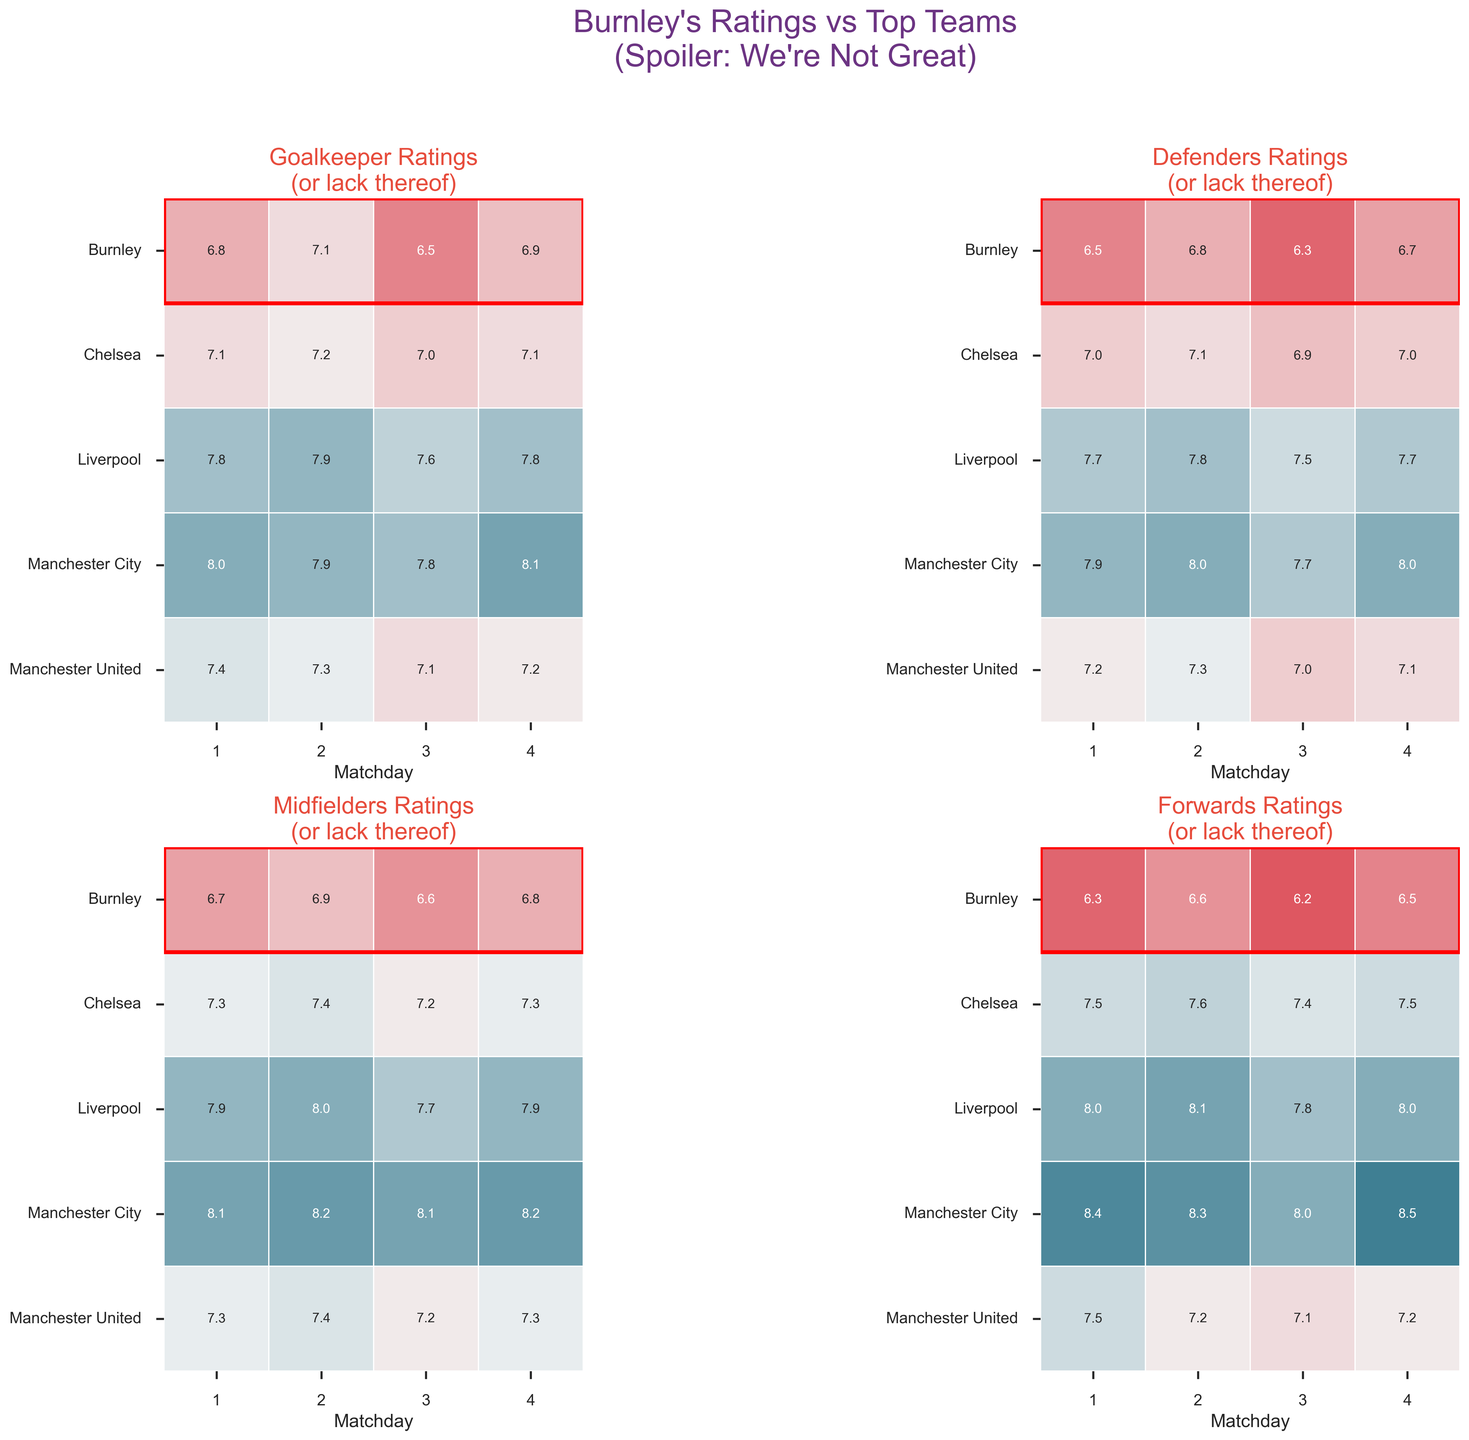What's the title of the figure? The title is right at the top of the figure. It reads: "Burnley's Ratings vs Top Teams (Spoiler: We're Not Great)"
Answer: Burnley's Ratings vs Top Teams (Spoiler: We're Not Great) What is the lowest rating for Burnley's Goalkeepers across the matches? By examining the heatmap for goalkeepers, we can see Burnley's ratings for matchdays 1 through 4. The ratings are 6.8, 7.1, 6.5, and 6.9. The lowest rating is 6.5 on matchday 3.
Answer: 6.5 Which team has the highest average rating for Midfielders over the four matchdays? First, we look at the Midfielders' heatmap. For each team, we calculate the average value of the four matchdays and compare them. Manchester City: (8.1 + 8.2 + 8.1 + 8.2) / 4 = 8.15, Manchester United: (7.3 + 7.4 + 7.2 + 7.3) / 4 = 7.3, Liverpool: (7.9 + 8.0 + 7.7 + 7.9) / 4 = 7.875, Chelsea: (7.3 + 7.4 + 7.2 + 7.3) / 4 = 7.3, Burnley: (6.7 + 6.9 + 6.6 + 6.8) / 4 = 6.75. So, Manchester City has the highest average.
Answer: Manchester City Comparing Matchday 1 ratings of Defenders, which team performs the worst? From the Defenders' heatmap, we check the ratings for each team on Matchday 1: Burnley: 6.5, Manchester City: 7.9, Manchester United: 7.2, Liverpool: 7.7, Chelsea: 7.0. The lowest rating on Matchday 1 for Defenders is Burnley's 6.5.
Answer: Burnley What's the average rating difference between Burnley's Midfielder and Manchester City's Midfielder on Matchday 4? For this, we note Burnley's Midfielder rating on Matchday 4 (6.8) and Manchester City's Midfielder rating (8.2). The difference is 8.2 - 6.8 = 1.4.
Answer: 1.4 What color palette is used in the figure? The question refers to the general appearance of the figure. It states that a custom colormap created using seaborn's diverging palette is used with the coding details kept out.
Answer: Diverging palette How many patches highlight Burnley in each heatmap? Each heatmap has been highlighted with a patch around Burnley's ratings. There are four heatmaps, one for each position, and each has a single red-highlighted patch for Burnley, making it four patches in total.
Answer: Four patches 